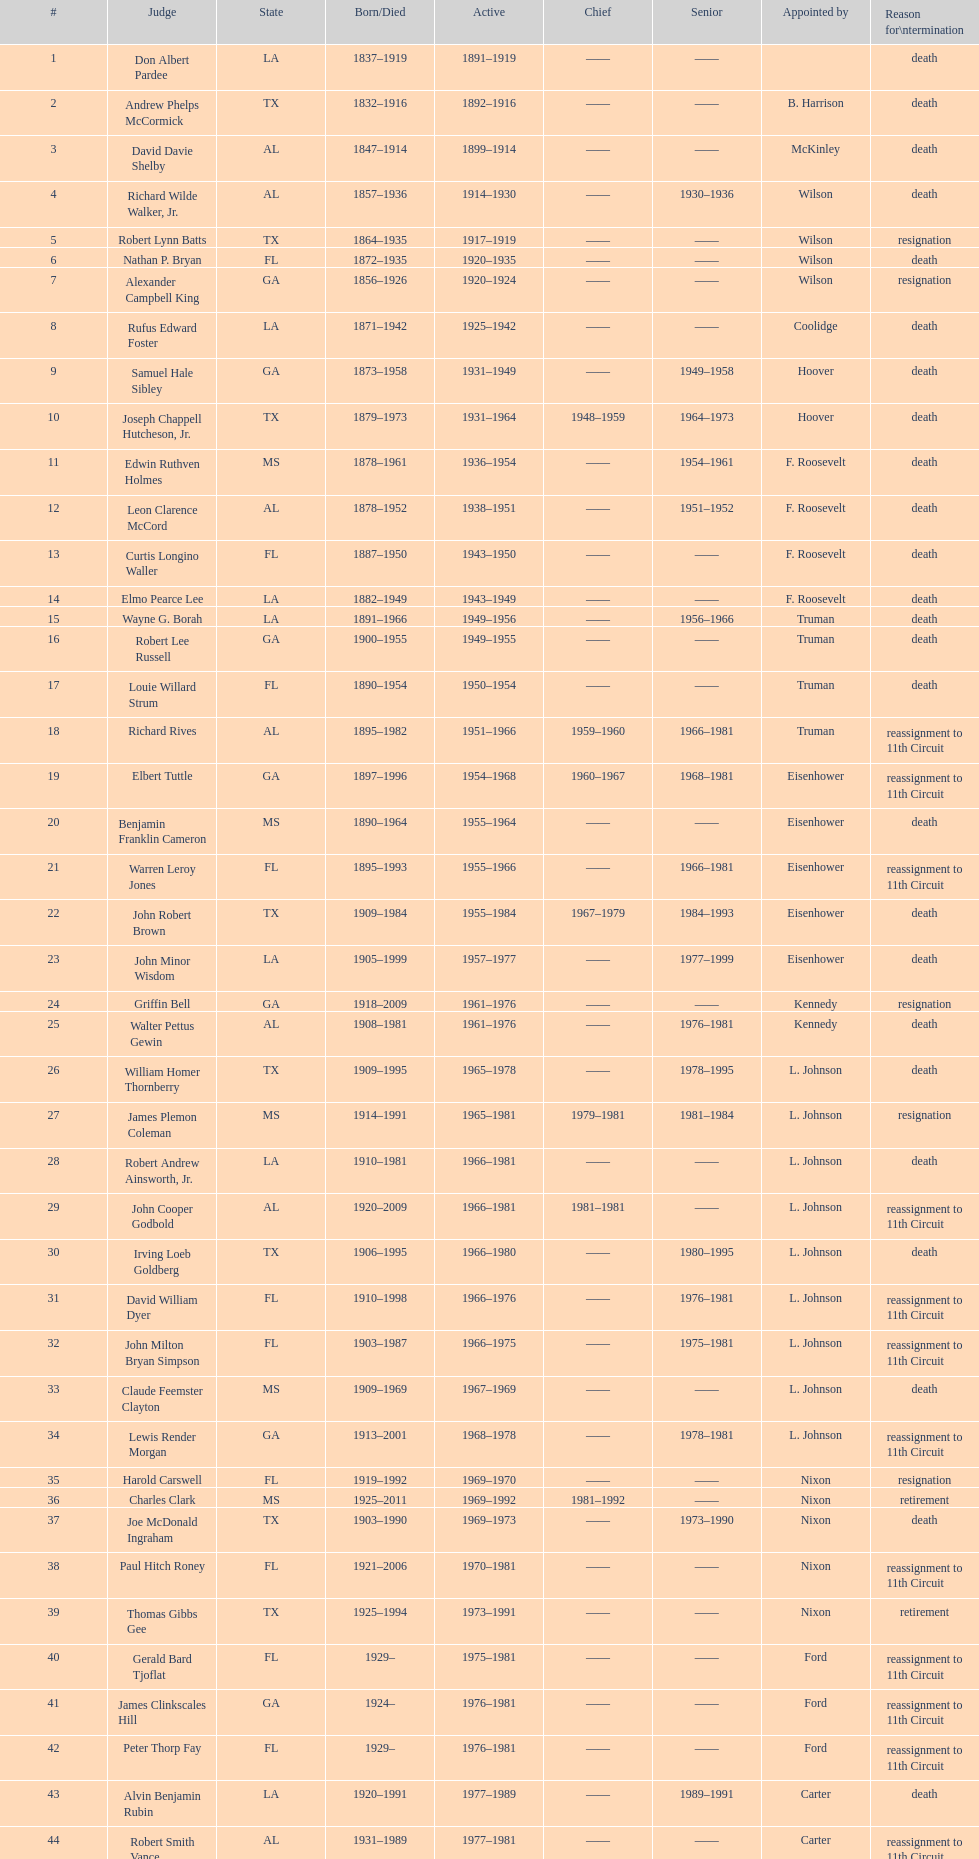In which state do the most judges serve? TX. 